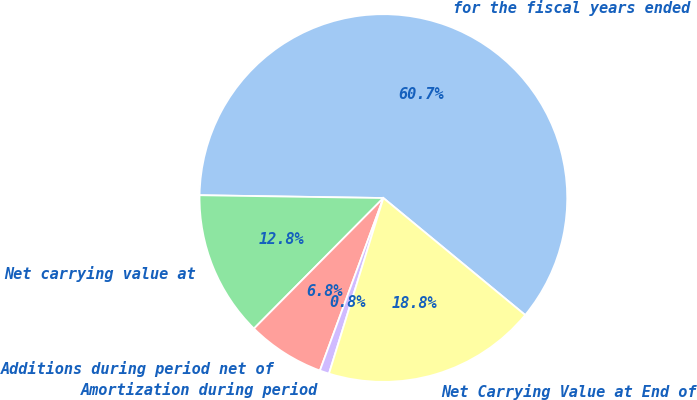Convert chart. <chart><loc_0><loc_0><loc_500><loc_500><pie_chart><fcel>for the fiscal years ended<fcel>Net carrying value at<fcel>Additions during period net of<fcel>Amortization during period<fcel>Net Carrying Value at End of<nl><fcel>60.73%<fcel>12.81%<fcel>6.82%<fcel>0.83%<fcel>18.8%<nl></chart> 